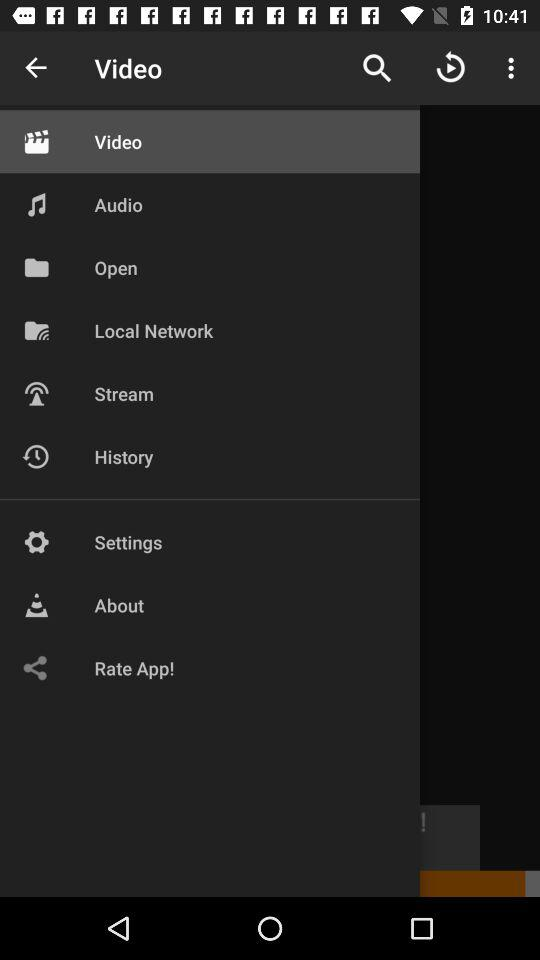Which item is selected in the menu? The selected item in the menu is "Video". 